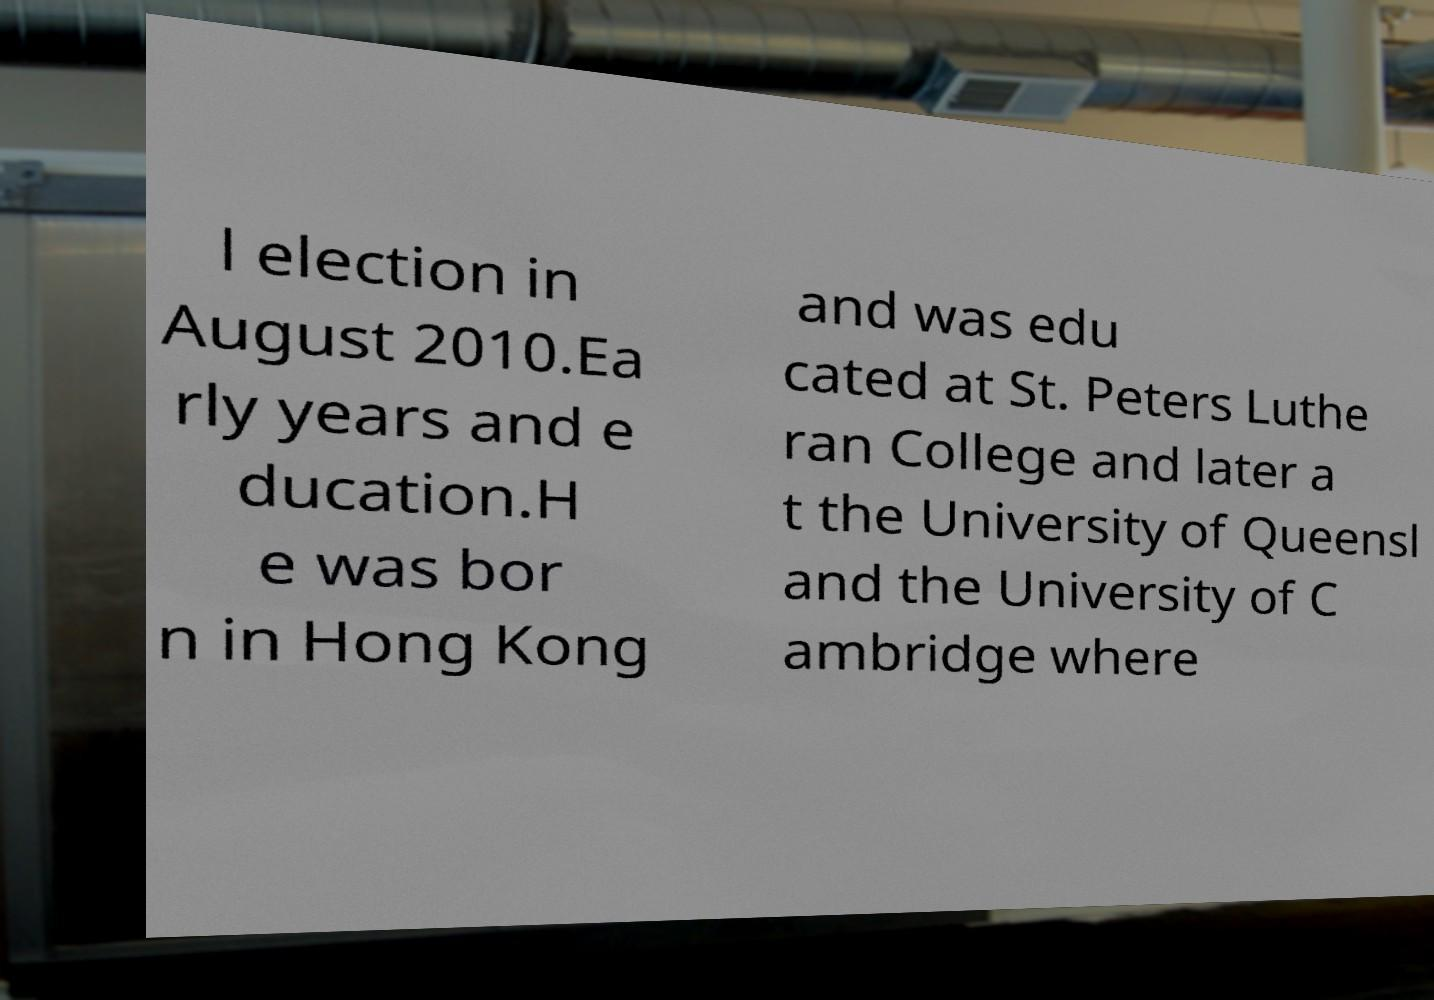Can you accurately transcribe the text from the provided image for me? l election in August 2010.Ea rly years and e ducation.H e was bor n in Hong Kong and was edu cated at St. Peters Luthe ran College and later a t the University of Queensl and the University of C ambridge where 